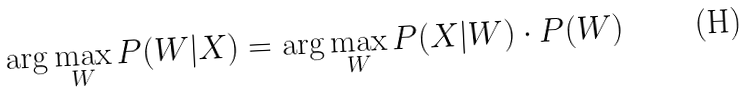<formula> <loc_0><loc_0><loc_500><loc_500>\arg \max _ { W } P ( W | X ) = \arg \max _ { W } P ( X | W ) \cdot P ( W )</formula> 